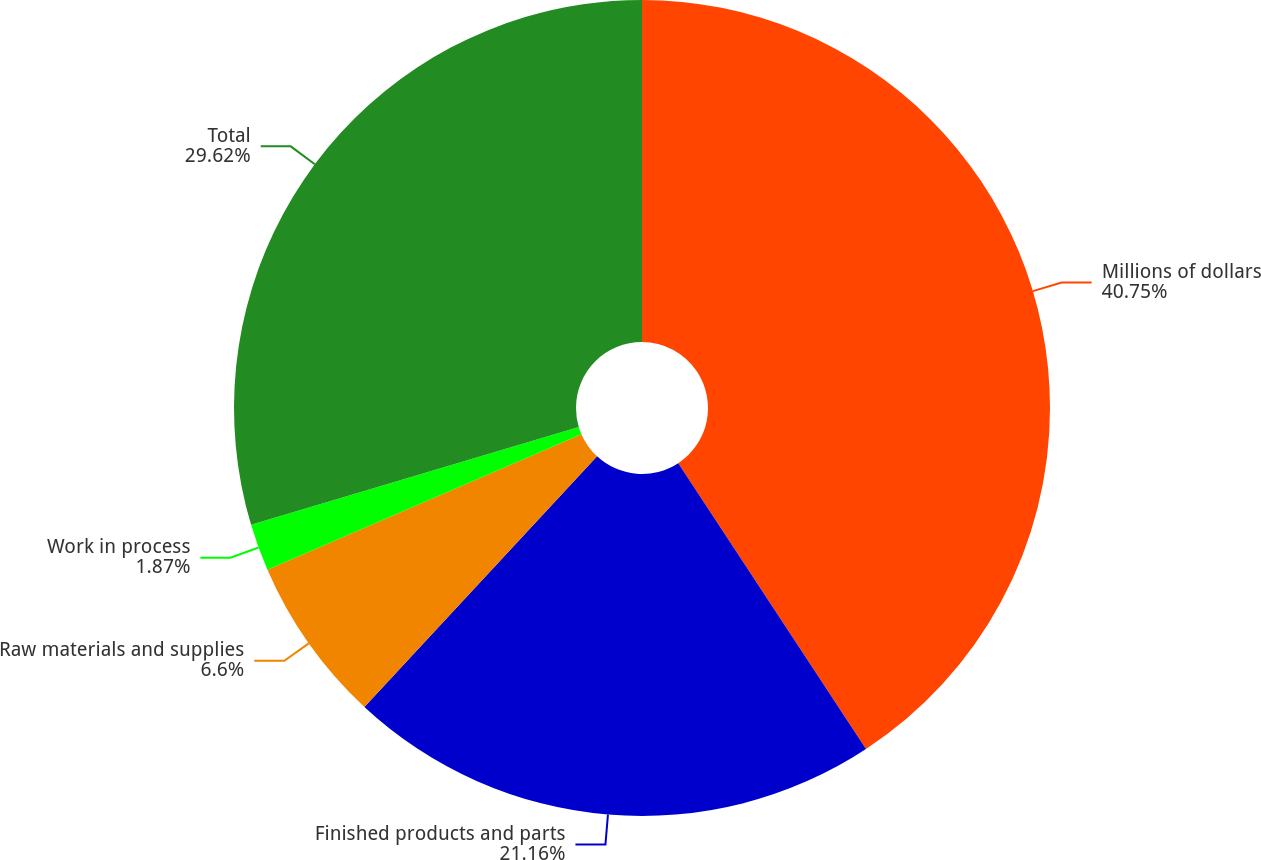<chart> <loc_0><loc_0><loc_500><loc_500><pie_chart><fcel>Millions of dollars<fcel>Finished products and parts<fcel>Raw materials and supplies<fcel>Work in process<fcel>Total<nl><fcel>40.75%<fcel>21.16%<fcel>6.6%<fcel>1.87%<fcel>29.62%<nl></chart> 